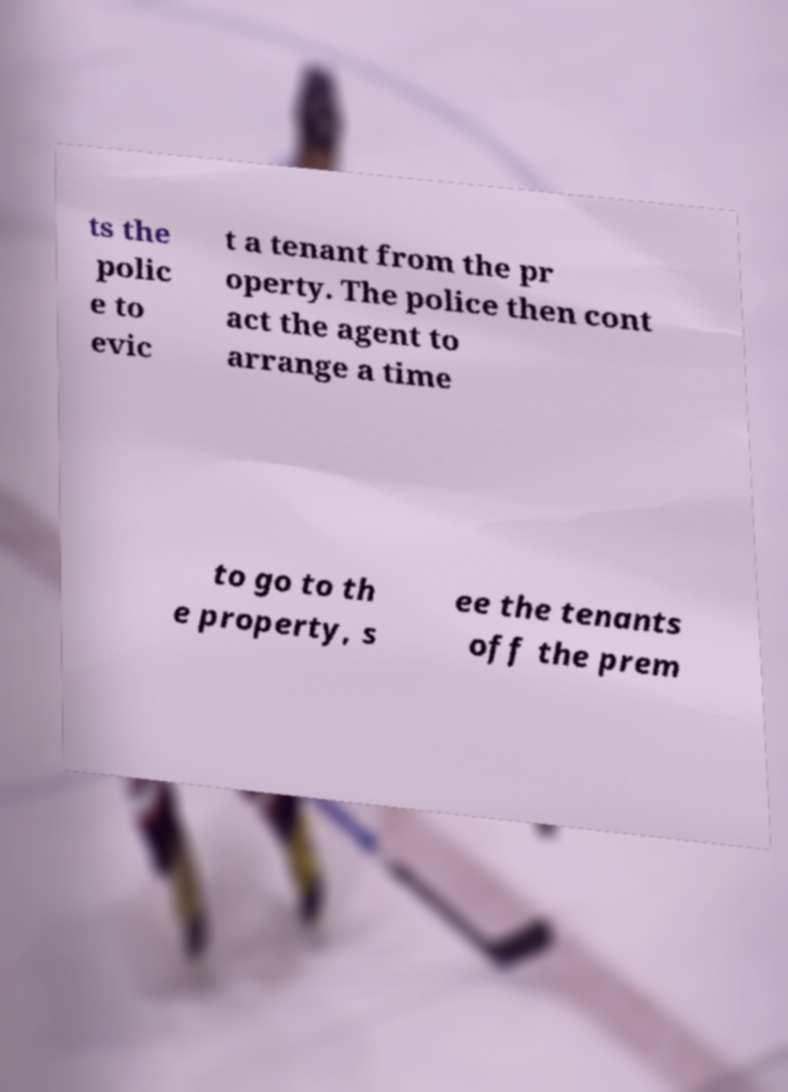What messages or text are displayed in this image? I need them in a readable, typed format. ts the polic e to evic t a tenant from the pr operty. The police then cont act the agent to arrange a time to go to th e property, s ee the tenants off the prem 